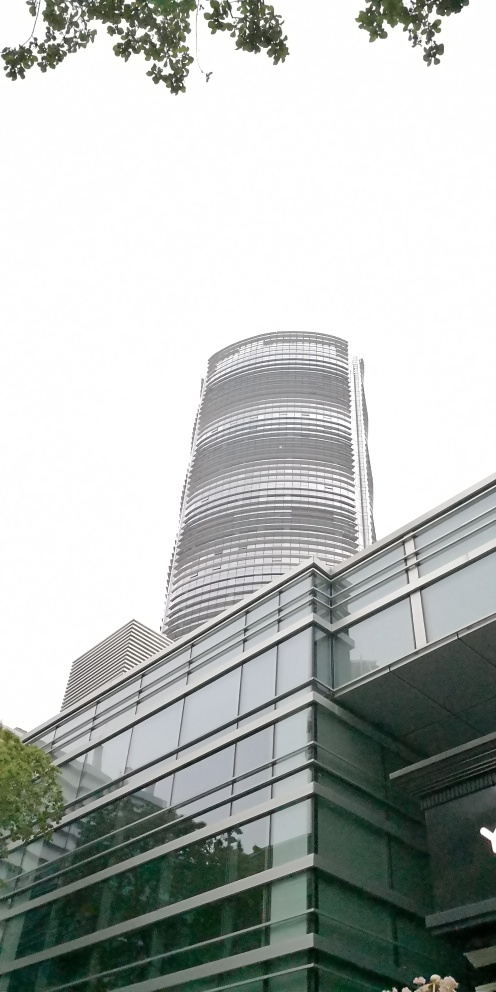Is the picture well-focused on the office building? Yes, the picture is well-focused on the office building, capturing its intricate design details and modern architecture clearly against the sky. The contrast between the natural elements in the foreground and the urban structure in the background is also quite striking. 